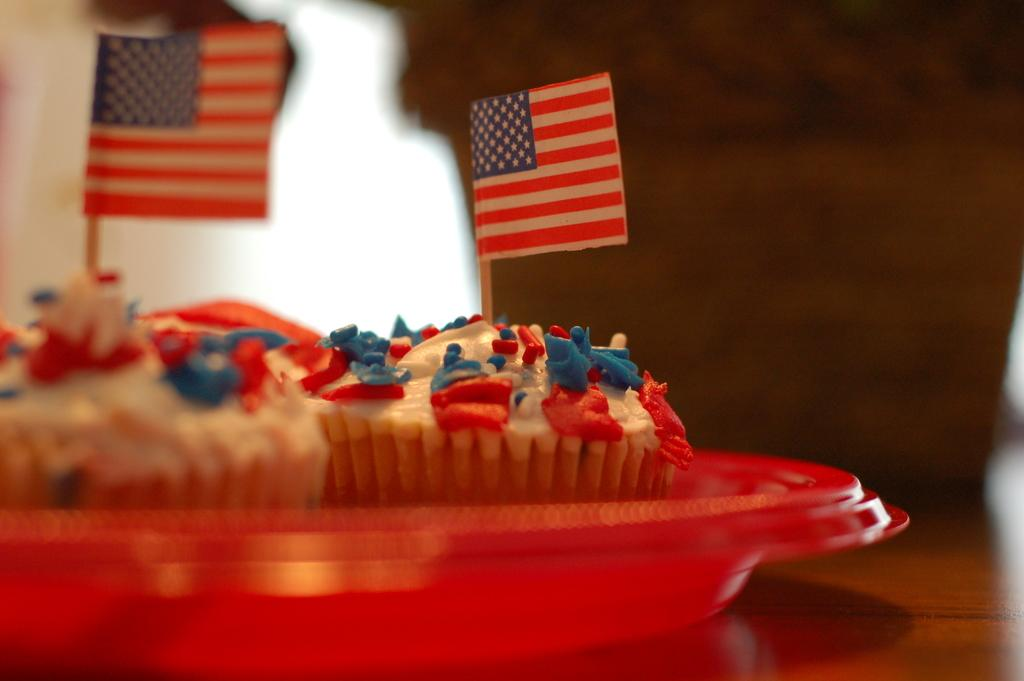What type of food is on the plate in the image? There are cupcakes on the plate in the image. Where is the plate with cupcakes located? The plate is placed on a table. What other objects can be seen in the image? There are two flags in the image. Can you describe the background of the image? The background of the image is blurred. How many tents are set up in the image? There are no tents present in the image. What type of battle is depicted in the image? There is no battle depicted in the image; it features cupcakes, a plate, flags, and a blurred background. 